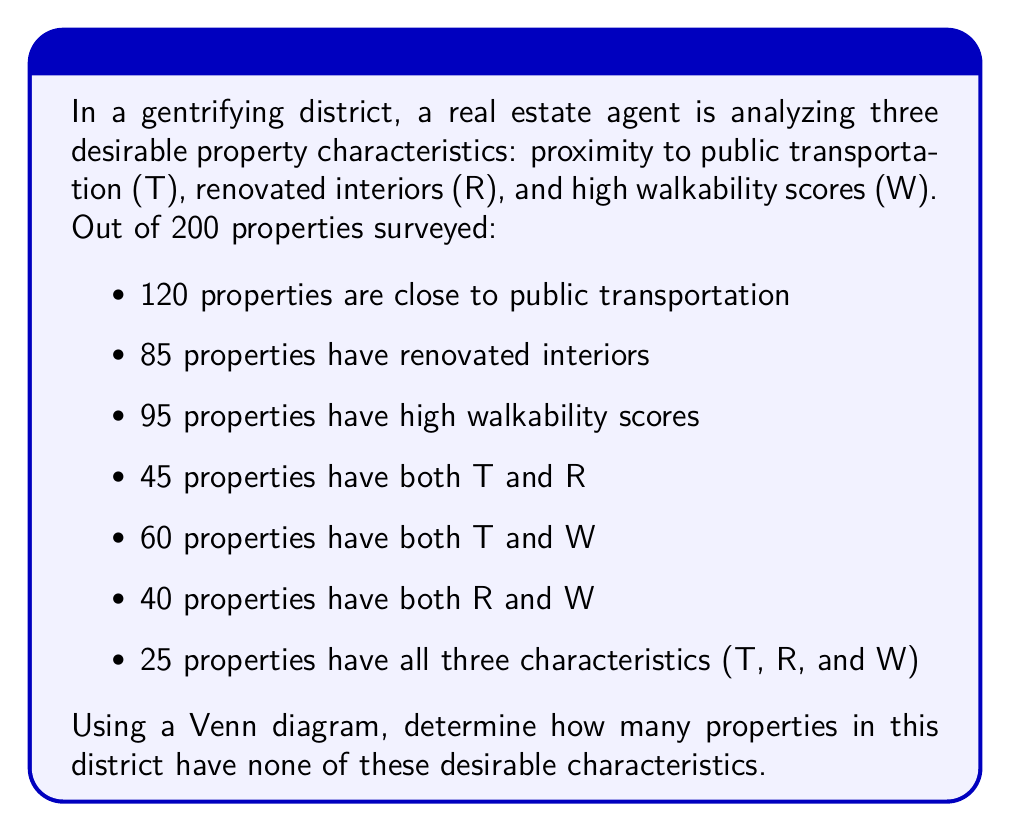Can you solve this math problem? Let's approach this step-by-step using a Venn diagram and set theory:

1) First, let's draw a Venn diagram with three overlapping circles representing T, R, and W.

[asy]
unitsize(1cm);

pair A = (0,0), B = (1.5,0), C = (0.75,1.3);
real r = 1.2;

draw(circle(A,r));
draw(circle(B,r));
draw(circle(C,r));

label("T", A + (-1,-1));
label("R", B + (1,-1));
label("W", C + (0,1.3));

label("25", (0.75,0.43));

label("20", (-0.4,0));
label("15", (1.9,0));
label("15", (0.75,1.3));

label("35", (0,0.65));
label("20", (1.5,0.65));
label("15", (0.75,-0.65));

[/asy]

2) We can fill in the Venn diagram with the given information:
   - 25 in the center (all three characteristics)
   - 45 for T ∩ R, so 20 in T ∩ R but not W
   - 60 for T ∩ W, so 35 in T ∩ W but not R
   - 40 for R ∩ W, so 15 in R ∩ W but not T

3) Now we can calculate the number in each circle:
   T only: 120 - (25 + 20 + 35) = 40
   R only: 85 - (25 + 20 + 15) = 25
   W only: 95 - (25 + 35 + 15) = 20

4) Let's sum up all the numbers in the Venn diagram:
   $$ 25 + 20 + 35 + 15 + 40 + 25 + 20 = 180 $$

5) The total number of properties is 200, so the number of properties with none of these characteristics is:
   $$ 200 - 180 = 20 $$

Therefore, 20 properties have none of these desirable characteristics.
Answer: 20 properties 